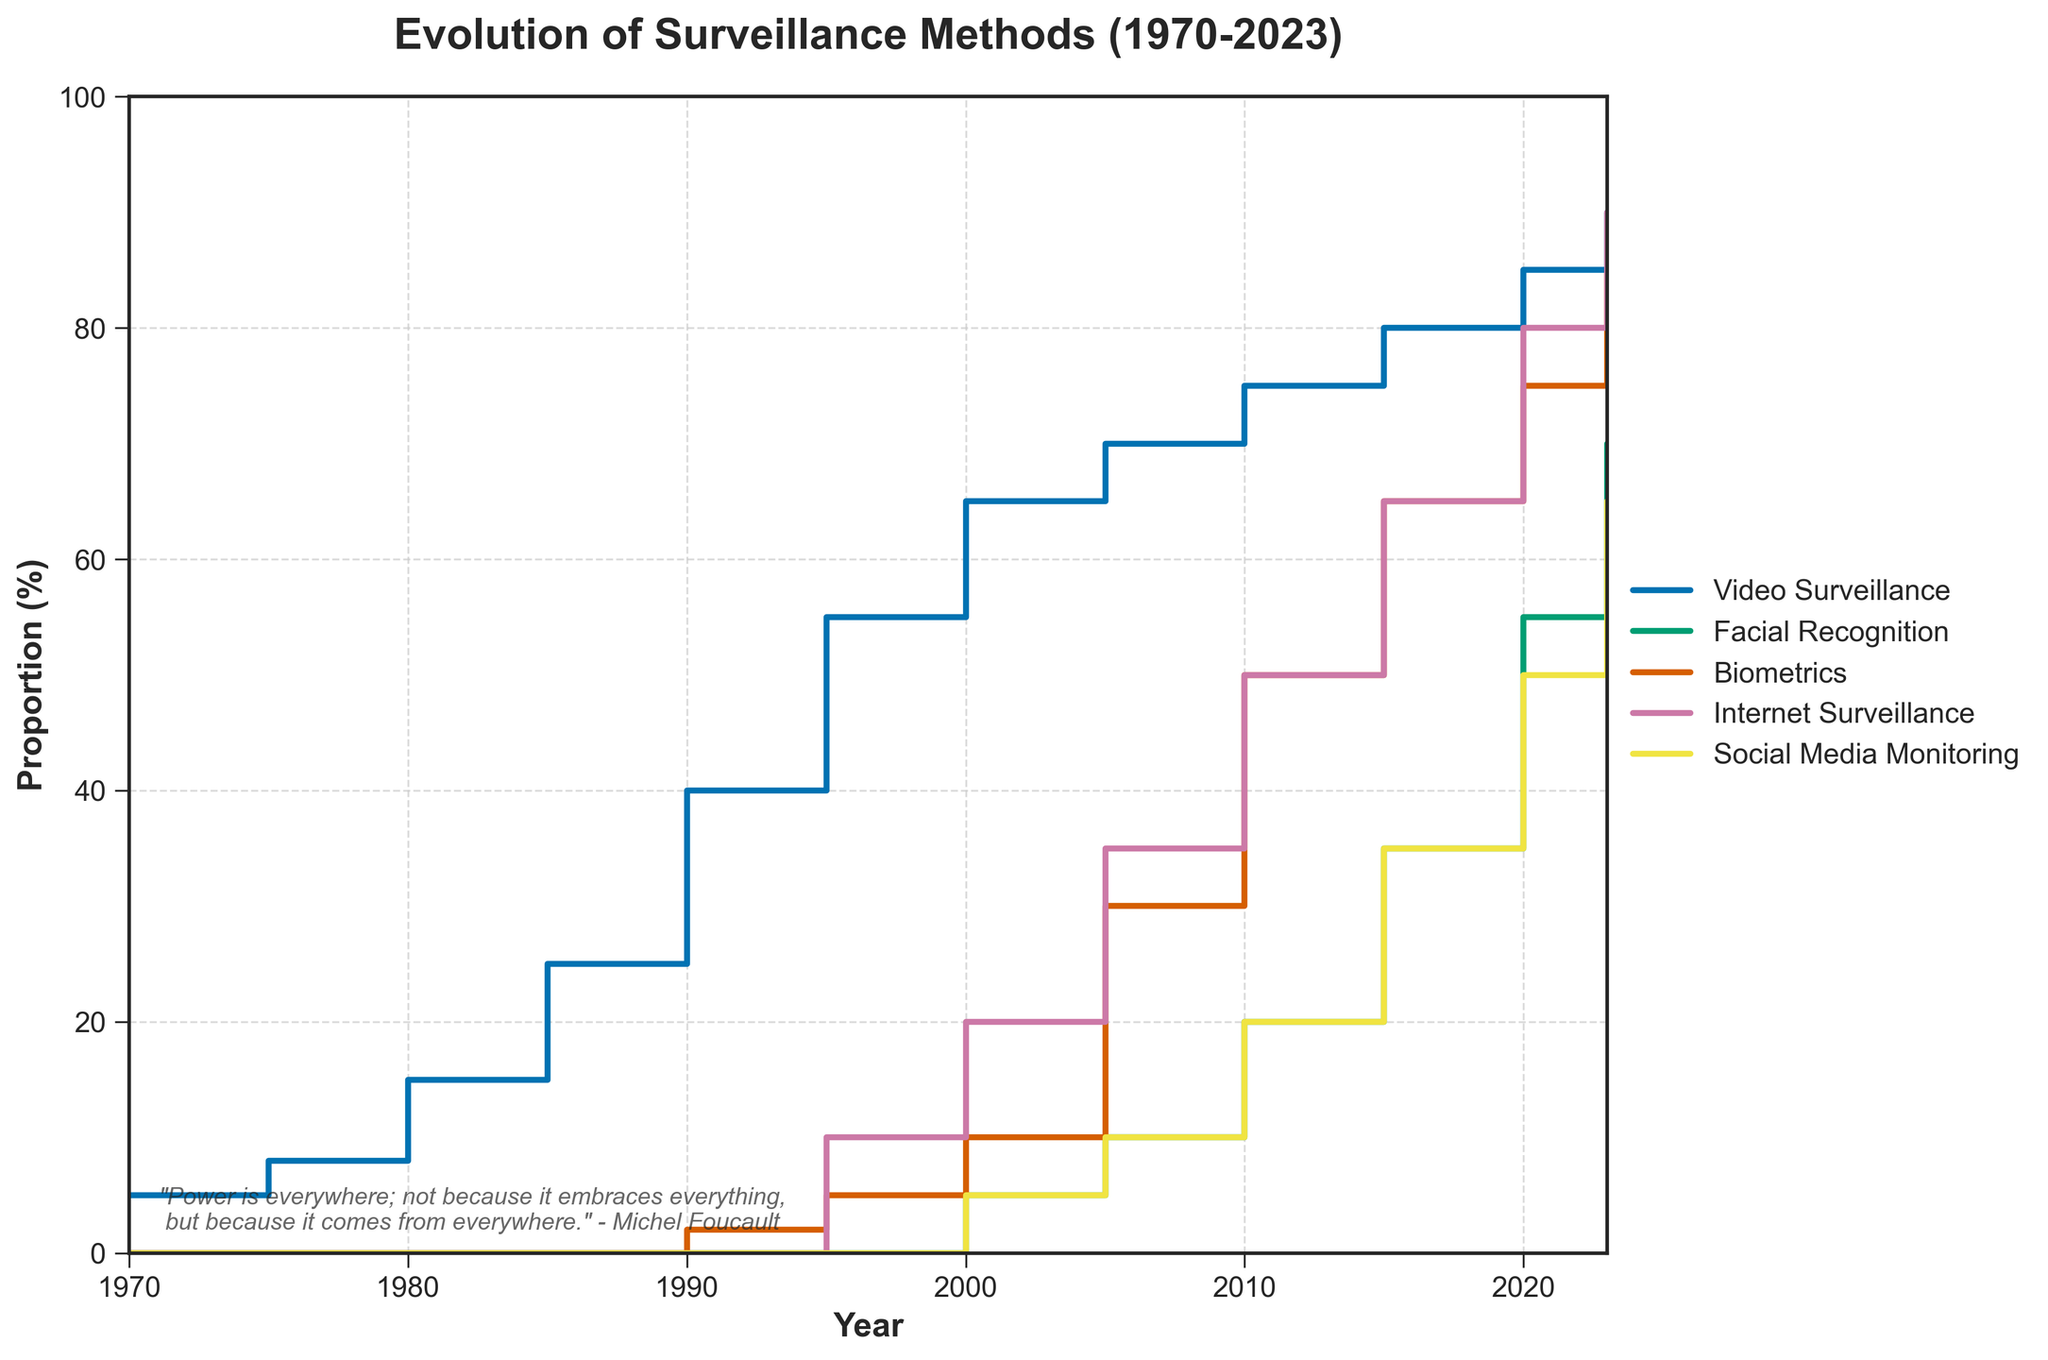What is the title of the plot? The title is typically located at the top center of the plot. The visual indicates it is "Evolution of Surveillance Methods (1970-2023)".
Answer: Evolution of Surveillance Methods (1970-2023) Which method showed the most significant increase in surveillance proportion from 1970 to 2023? By observing the step heights between 1970 and 2023, Video Surveillance shows the largest increase, from 5% to 90%.
Answer: Video Surveillance How did the proportion of Internet Surveillance change from 1995 to 2023? Internet Surveillance starts at 10% in 1995, rises gradually, and reaches 90% by 2023, showing a major increase.
Answer: Increased from 10% to 90% What was the proportion of Facial Recognition in 2000 compared to 2005? In 2000, Facial Recognition was at 5% and increased to 10% by 2005, doubling its proportion.
Answer: 5% in 2000, 10% in 2005 Among all the surveillance methods, which one had the smallest proportion in the 1970s? Examining the data between 1970 and 1980, all methods except Video Surveillance had 0%, making them the smallest proportions.
Answer: Facial Recognition, Biometrics, Internet Surveillance, and Social Media Monitoring What is the total proportion of all surveillance methods combined in 2010? Adding the proportions in 2010, Video Surveillance (75%) + Facial Recognition (20%) + Biometrics (50%) + Internet Surveillance (50%) + Social Media Monitoring (20%) equals 215%.
Answer: 215% Which surveillance method started being used first according to the plot? Video Surveillance is the only method present in 1970, indicating it was the first.
Answer: Video Surveillance In which year did Biometrics first appear and what was its proportion? Biometrics first appears in 1990 with a proportion of 2%.
Answer: 1990, 2% By what percentage did Social Media Monitoring grow from 2000 to 2023? Starting at 5% in 2000 and growing to 65% by 2023, the increase is 60%.
Answer: 60% Out of the five surveillance methods, which two had the same proportion in 2010? In 2010, both Biometrics and Internet Surveillance had a proportion of 50%.
Answer: Biometrics and Internet Surveillance 